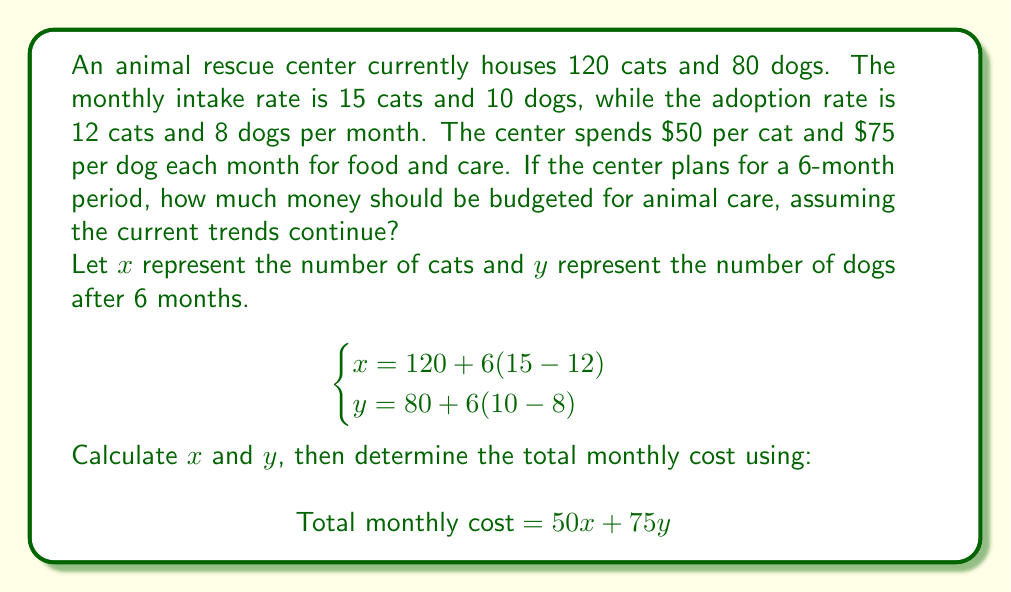Can you solve this math problem? To solve this problem, we'll follow these steps:

1. Calculate the number of cats and dogs after 6 months:

For cats:
$$x = 120 + 6(15 - 12) = 120 + 6(3) = 120 + 18 = 138$$

For dogs:
$$y = 80 + 6(10 - 8) = 80 + 6(2) = 80 + 12 = 92$$

2. Calculate the monthly cost for cats:
$$\text{Cat cost} = 50 \times 138 = $6,900$$

3. Calculate the monthly cost for dogs:
$$\text{Dog cost} = 75 \times 92 = $6,900$$

4. Sum up the total monthly cost:
$$\text{Total monthly cost} = $6,900 + $6,900 = $13,800$$

5. Calculate the budget for 6 months:
$$\text{6-month budget} = $13,800 \times 6 = $82,800$$

Therefore, the animal rescue center should budget $82,800 for animal care over the 6-month period.
Answer: $82,800 